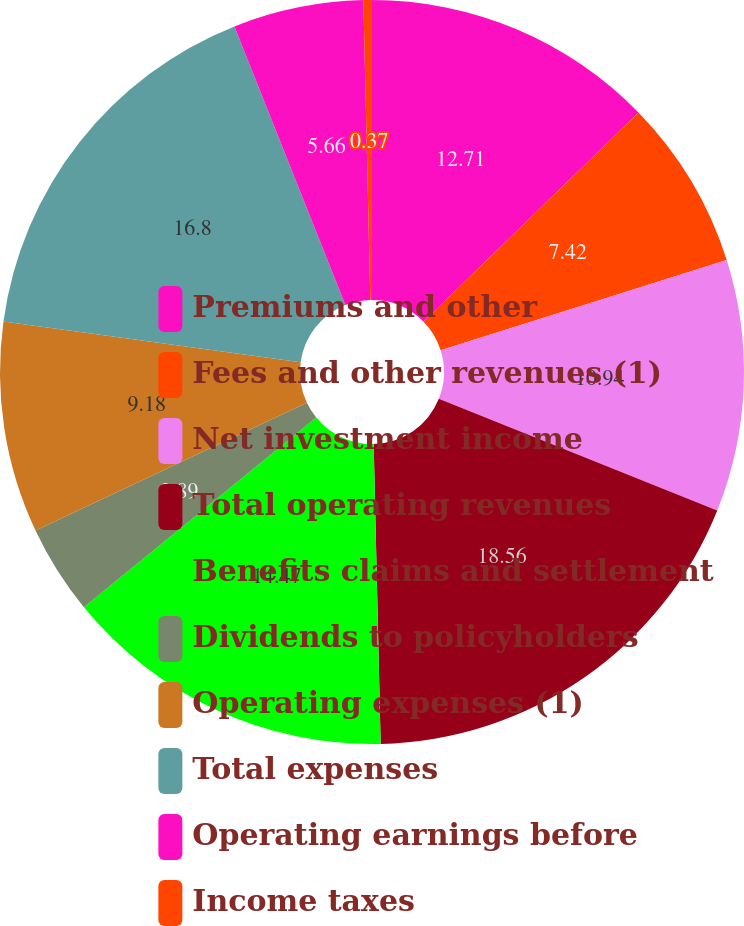Convert chart to OTSL. <chart><loc_0><loc_0><loc_500><loc_500><pie_chart><fcel>Premiums and other<fcel>Fees and other revenues (1)<fcel>Net investment income<fcel>Total operating revenues<fcel>Benefits claims and settlement<fcel>Dividends to policyholders<fcel>Operating expenses (1)<fcel>Total expenses<fcel>Operating earnings before<fcel>Income taxes<nl><fcel>12.71%<fcel>7.42%<fcel>10.94%<fcel>18.56%<fcel>14.47%<fcel>3.89%<fcel>9.18%<fcel>16.8%<fcel>5.66%<fcel>0.37%<nl></chart> 